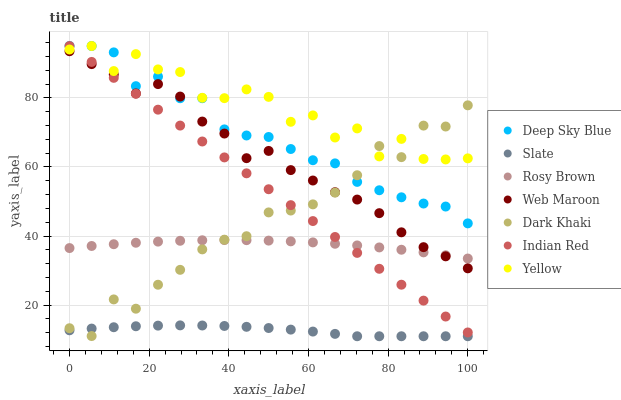Does Slate have the minimum area under the curve?
Answer yes or no. Yes. Does Yellow have the maximum area under the curve?
Answer yes or no. Yes. Does Rosy Brown have the minimum area under the curve?
Answer yes or no. No. Does Rosy Brown have the maximum area under the curve?
Answer yes or no. No. Is Indian Red the smoothest?
Answer yes or no. Yes. Is Yellow the roughest?
Answer yes or no. Yes. Is Slate the smoothest?
Answer yes or no. No. Is Slate the roughest?
Answer yes or no. No. Does Slate have the lowest value?
Answer yes or no. Yes. Does Rosy Brown have the lowest value?
Answer yes or no. No. Does Indian Red have the highest value?
Answer yes or no. Yes. Does Rosy Brown have the highest value?
Answer yes or no. No. Is Rosy Brown less than Yellow?
Answer yes or no. Yes. Is Rosy Brown greater than Slate?
Answer yes or no. Yes. Does Dark Khaki intersect Rosy Brown?
Answer yes or no. Yes. Is Dark Khaki less than Rosy Brown?
Answer yes or no. No. Is Dark Khaki greater than Rosy Brown?
Answer yes or no. No. Does Rosy Brown intersect Yellow?
Answer yes or no. No. 